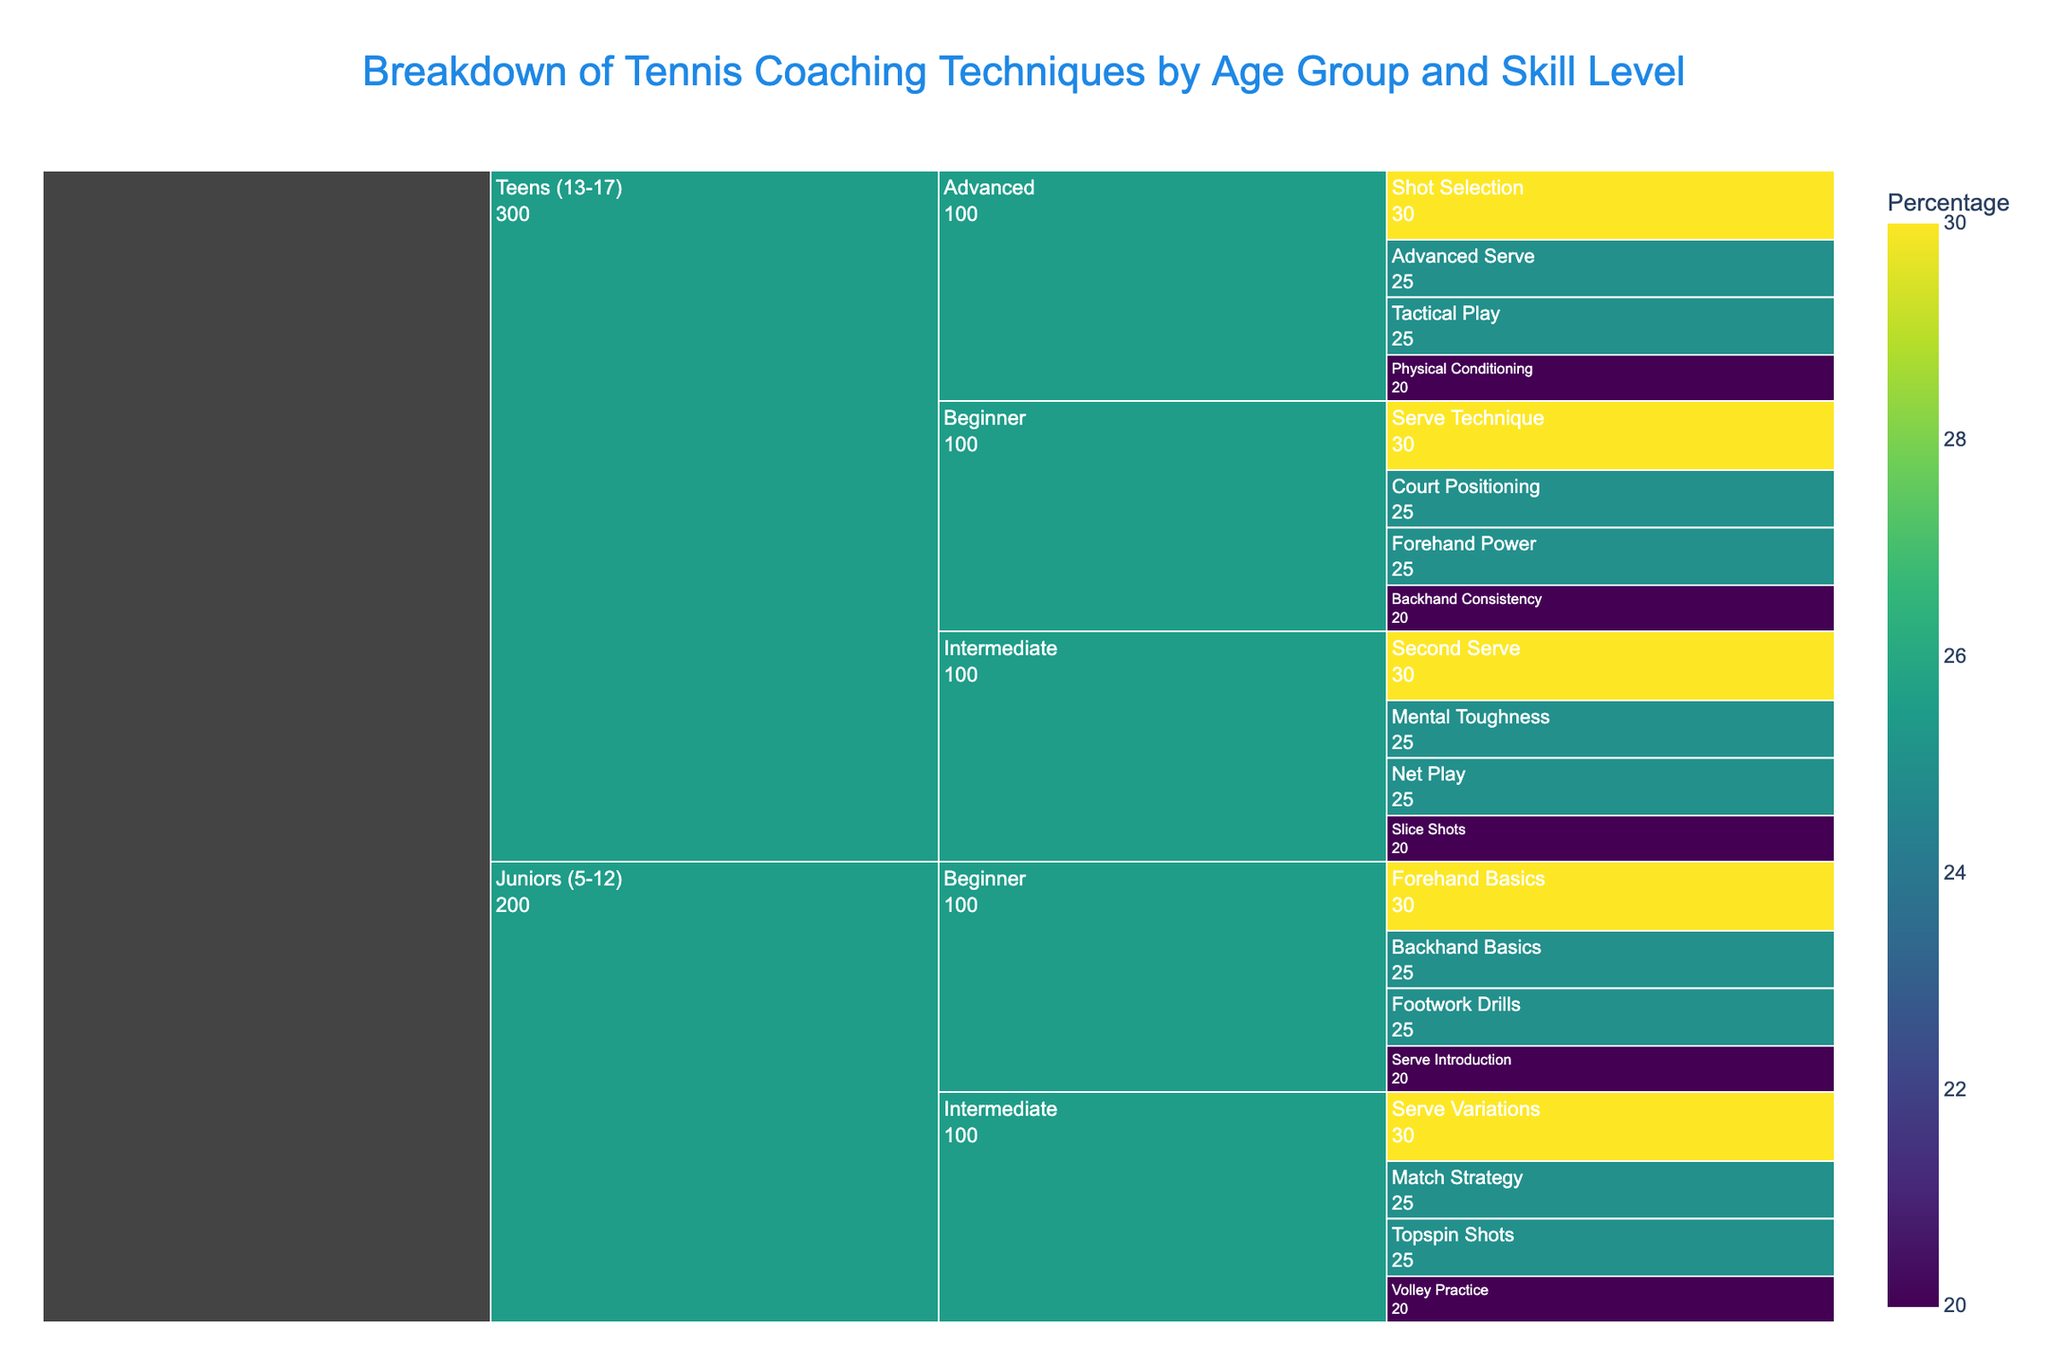How is the breakdown of coaching focuses for Juniors (5-12) different between beginners and intermediates? To answer this, look at the techniques listed under the Juniors (5-12) age group for both Beginner and Intermediate levels. Beginners focus on foundational skills like Forehand Basics (30%), Backhand Basics (25%), Serve Introduction (20%), and Footwork Drills (25%). Intermediates, however, focus more on advanced techniques like Topspin Shots (25%), Volley Practice (20%), Serve Variations (30%), and Match Strategy (25%).
Answer: Beginners focus more on basic techniques while intermediates focus on more advanced skills Which technique has the highest percentage among Teens (13-17) at the beginner level? Within the Teens (13-17) age group, look at the Beginner skill level and identify the technique with the highest percentage. The options are Forehand Power (25%), Backhand Consistency (20%), Serve Technique (30%), and Court Positioning (25%). The highest percentage is Serve Technique with 30%.
Answer: Serve Technique What is the combined percentage focus on serve-related techniques for Intermediate skill level across all age groups? To find this, sum the percentage values for serve-related techniques within the Intermediate skill level for each age group. For Juniors (5-12) Intermediate, Serve Variations is 30%. For Teens (13-17) Intermediate, Second Serve is 30%. Adding these gives 30% + 30% = 60%.
Answer: 60% In the Icicle Chart, which age group has the more diversified set of techniques at the Advanced skill level? Compare the number of techniques listed for the Advanced skill level in each age group. For Teens (13-17), there are four techniques: Shot Selection (30%), Advanced Serve (25%), Tactical Play (25%), and Physical Conditioning (20%). Juniors (5-12) do not have an Advanced skill level listed. So, the more diversified set of techniques at the Advanced level belongs to Teens (13-17).
Answer: Teens (13-17) What is the least focused-on technique for Teens (13-17) at the Intermediate skill level? Within the Teens (13-17) age group, look at the Intermediate skill level techniques and their percentages. Slice Shots (20%), Net Play (25%), Second Serve (30%), and Mental Toughness (25%). The least focused-on technique here is Slice Shots with 20%.
Answer: Slice Shots 